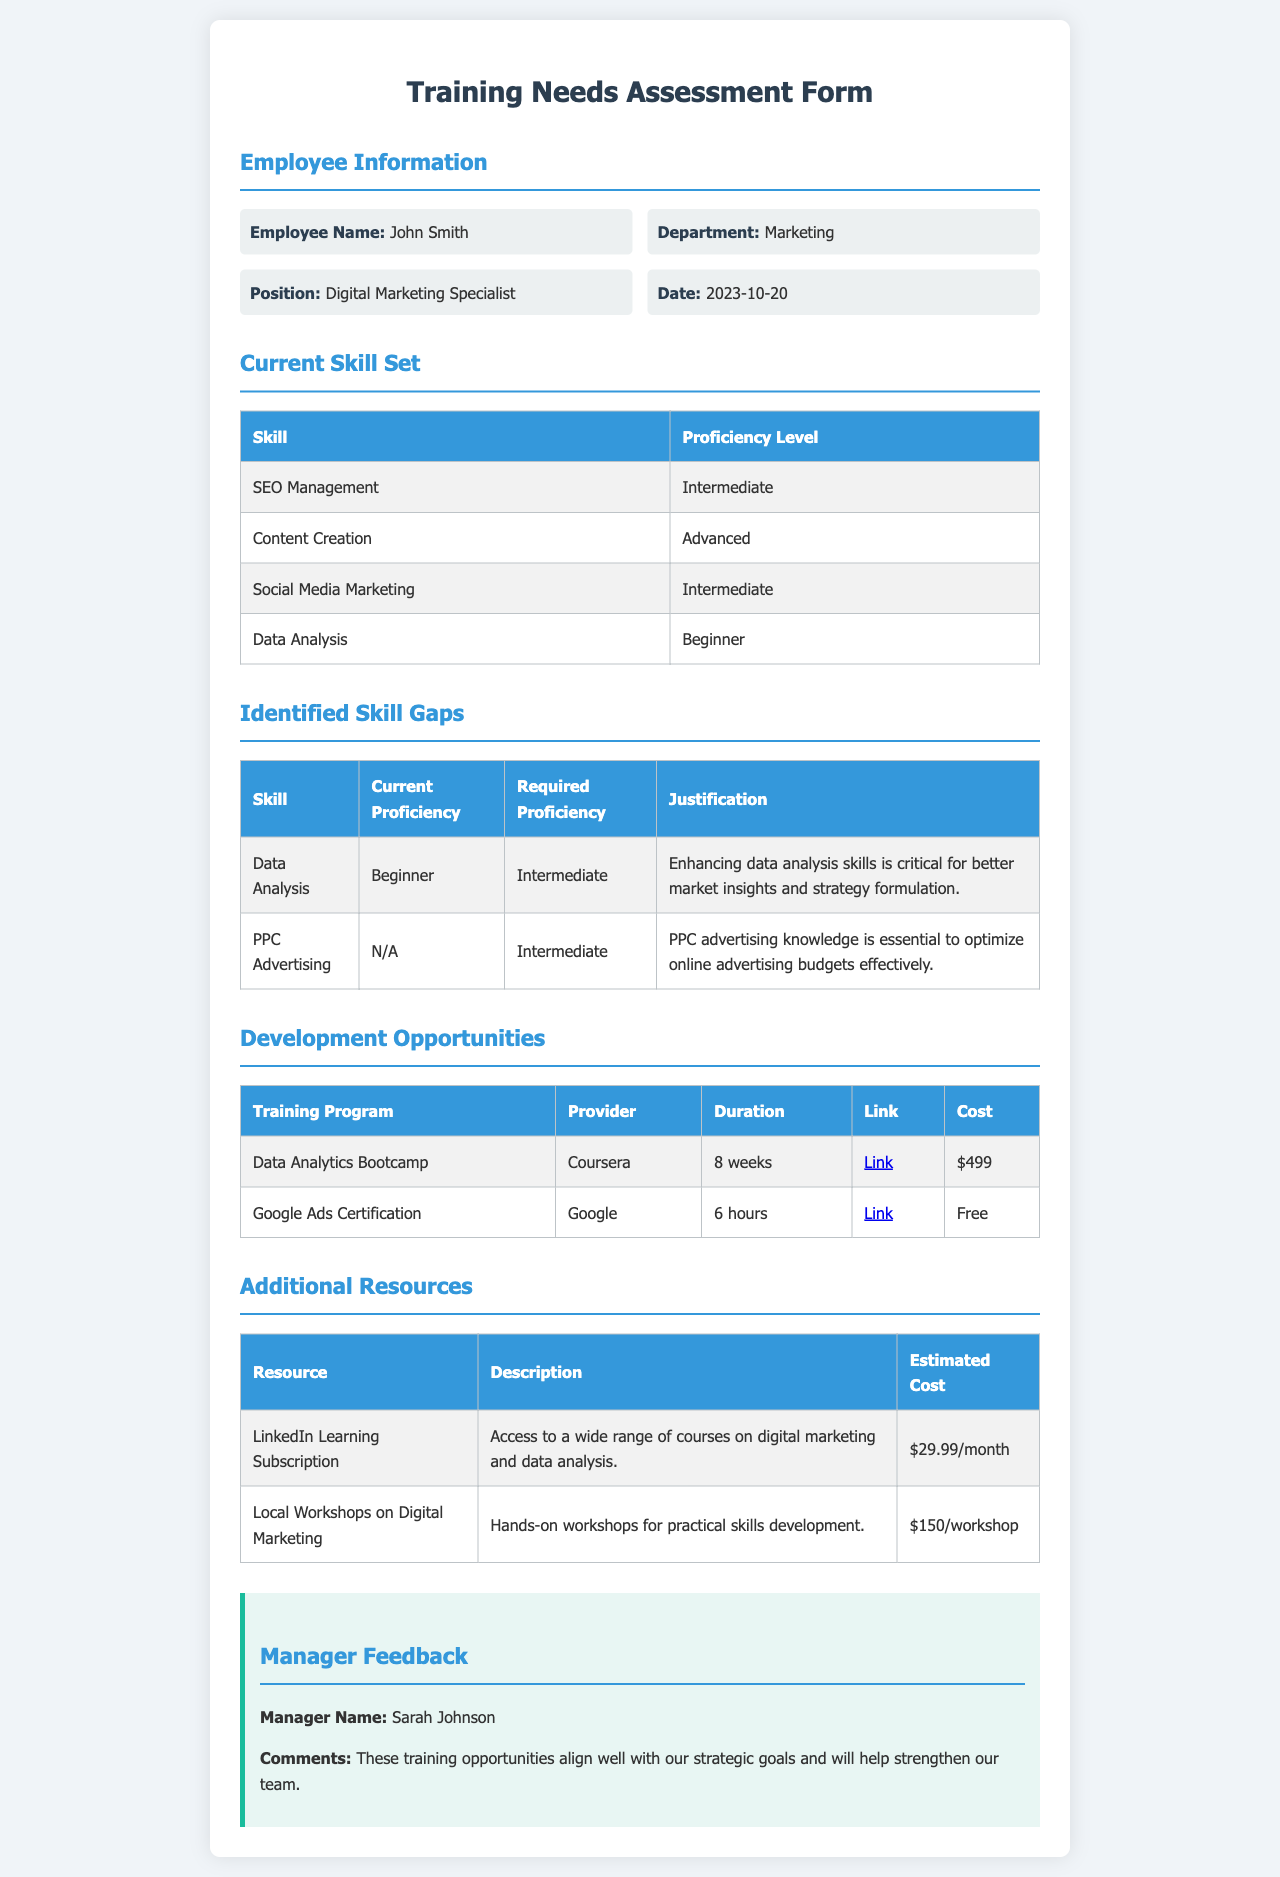What is the employee's name? The employee's name is provided in the Employee Information section of the document.
Answer: John Smith What is the department of the employee? The department is listed next to the employee's name in the Employee Information section.
Answer: Marketing What is the current proficiency level of Data Analysis? The proficiency level can be found in the Current Skill Set table corresponding to Data Analysis.
Answer: Beginner What is the required proficiency level for Data Analysis? The required proficiency level is indicated in the Identified Skill Gaps table for Data Analysis.
Answer: Intermediate What is the cost of the Data Analytics Bootcamp? The cost is displayed in the Development Opportunities table, under the cost column for the respective training program.
Answer: $499 What is the duration of the Google Ads Certification? The duration is mentioned in the Development Opportunities table for the Google Ads Certification training program.
Answer: 6 hours Which skill gap is justified by the need for better market insights? The justification for the identified skill gap can be found in the Identified Skill Gaps table.
Answer: Data Analysis What platform offers the Google Ads Certification? The provider of the Google Ads Certification is mentioned in the Development Opportunities table.
Answer: Google What is one of the additional resources listed in the document? The resources are provided in a separate table.
Answer: LinkedIn Learning Subscription What is the manager's name providing feedback? The manager's name is provided in the Manager Feedback section of the document.
Answer: Sarah Johnson 